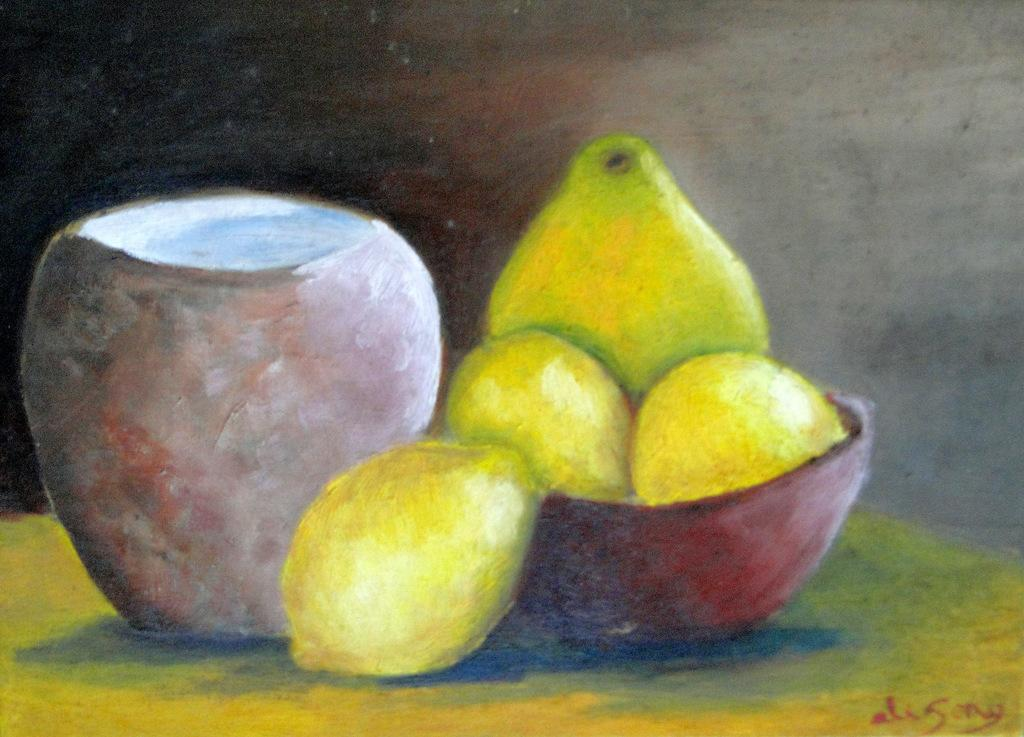What type of artwork is depicted in the image? The image is a painting. What objects can be seen in the painting? There is a pot and a bowl in the painting. What else is featured in the painting besides the pot and bowl? There are fruits in the painting. What type of baseball can be seen in the painting? There is no baseball present in the painting; it features a pot, a bowl, and fruits. What color is the button on the pot in the painting? There is no button on the pot in the painting; it only features the pot and other objects mentioned. 